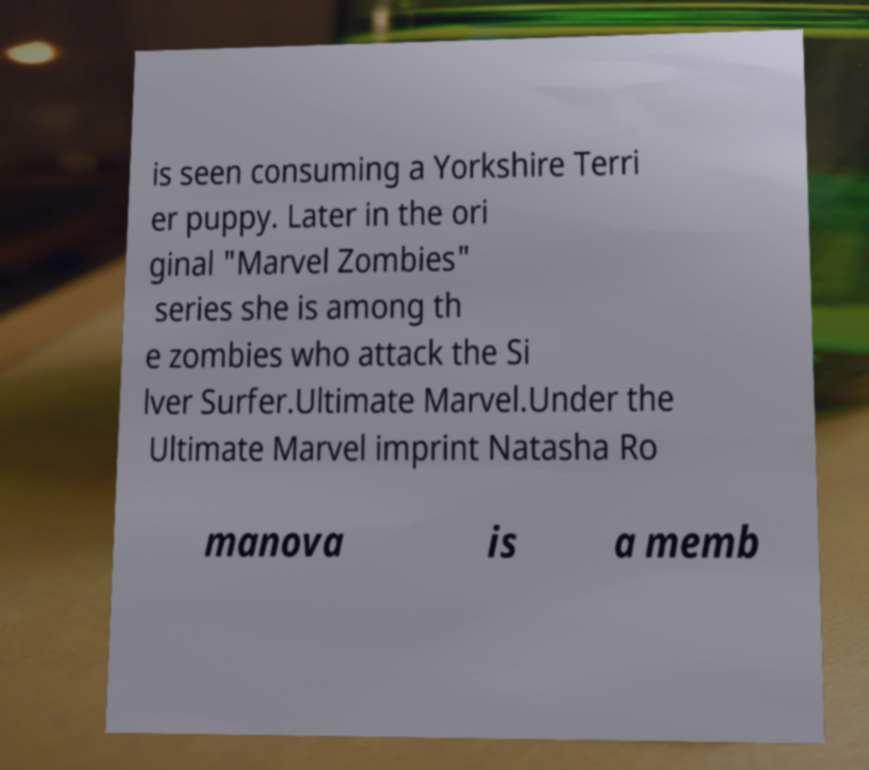Could you assist in decoding the text presented in this image and type it out clearly? is seen consuming a Yorkshire Terri er puppy. Later in the ori ginal "Marvel Zombies" series she is among th e zombies who attack the Si lver Surfer.Ultimate Marvel.Under the Ultimate Marvel imprint Natasha Ro manova is a memb 